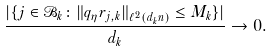<formula> <loc_0><loc_0><loc_500><loc_500>\frac { | \{ j \in \mathcal { B } _ { k } \colon \| q _ { \eta } r _ { j , k } \| _ { \ell ^ { 2 } ( d _ { k } n ) } \leq M _ { k } \} | } { d _ { k } } \to 0 .</formula> 